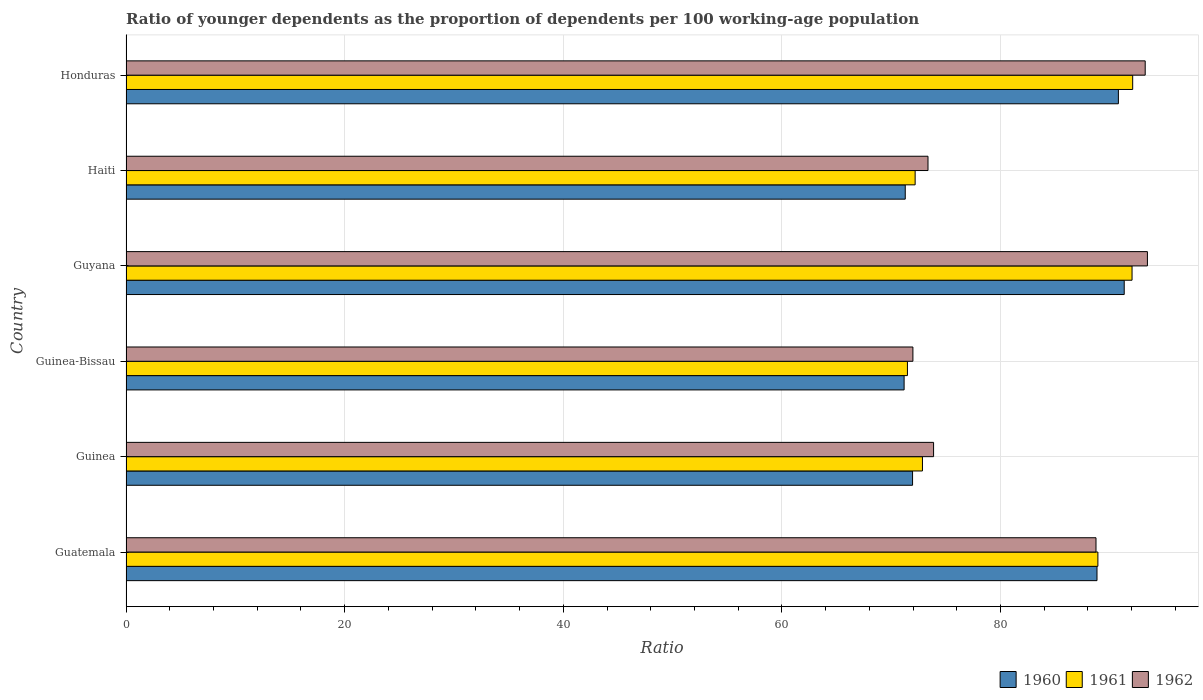Are the number of bars per tick equal to the number of legend labels?
Make the answer very short. Yes. Are the number of bars on each tick of the Y-axis equal?
Your response must be concise. Yes. How many bars are there on the 2nd tick from the top?
Your response must be concise. 3. How many bars are there on the 4th tick from the bottom?
Your answer should be very brief. 3. What is the label of the 5th group of bars from the top?
Ensure brevity in your answer.  Guinea. In how many cases, is the number of bars for a given country not equal to the number of legend labels?
Offer a terse response. 0. What is the age dependency ratio(young) in 1961 in Guyana?
Make the answer very short. 92.03. Across all countries, what is the maximum age dependency ratio(young) in 1961?
Your response must be concise. 92.09. Across all countries, what is the minimum age dependency ratio(young) in 1962?
Ensure brevity in your answer.  71.98. In which country was the age dependency ratio(young) in 1962 maximum?
Ensure brevity in your answer.  Guyana. In which country was the age dependency ratio(young) in 1962 minimum?
Your response must be concise. Guinea-Bissau. What is the total age dependency ratio(young) in 1962 in the graph?
Ensure brevity in your answer.  494.63. What is the difference between the age dependency ratio(young) in 1962 in Guatemala and that in Honduras?
Offer a very short reply. -4.5. What is the difference between the age dependency ratio(young) in 1962 in Guyana and the age dependency ratio(young) in 1960 in Guinea?
Offer a very short reply. 21.49. What is the average age dependency ratio(young) in 1961 per country?
Give a very brief answer. 81.59. What is the difference between the age dependency ratio(young) in 1961 and age dependency ratio(young) in 1960 in Haiti?
Keep it short and to the point. 0.9. What is the ratio of the age dependency ratio(young) in 1960 in Guinea-Bissau to that in Guyana?
Keep it short and to the point. 0.78. Is the age dependency ratio(young) in 1960 in Guatemala less than that in Haiti?
Provide a short and direct response. No. Is the difference between the age dependency ratio(young) in 1961 in Guatemala and Guinea-Bissau greater than the difference between the age dependency ratio(young) in 1960 in Guatemala and Guinea-Bissau?
Ensure brevity in your answer.  No. What is the difference between the highest and the second highest age dependency ratio(young) in 1960?
Your response must be concise. 0.53. What is the difference between the highest and the lowest age dependency ratio(young) in 1962?
Offer a very short reply. 21.45. Is the sum of the age dependency ratio(young) in 1962 in Guatemala and Guinea greater than the maximum age dependency ratio(young) in 1960 across all countries?
Your answer should be very brief. Yes. Are all the bars in the graph horizontal?
Provide a succinct answer. Yes. What is the difference between two consecutive major ticks on the X-axis?
Make the answer very short. 20. Are the values on the major ticks of X-axis written in scientific E-notation?
Your response must be concise. No. Does the graph contain any zero values?
Give a very brief answer. No. Does the graph contain grids?
Your answer should be compact. Yes. Where does the legend appear in the graph?
Your answer should be compact. Bottom right. How many legend labels are there?
Offer a very short reply. 3. How are the legend labels stacked?
Your response must be concise. Horizontal. What is the title of the graph?
Provide a short and direct response. Ratio of younger dependents as the proportion of dependents per 100 working-age population. What is the label or title of the X-axis?
Your response must be concise. Ratio. What is the label or title of the Y-axis?
Give a very brief answer. Country. What is the Ratio of 1960 in Guatemala?
Provide a succinct answer. 88.83. What is the Ratio of 1961 in Guatemala?
Offer a very short reply. 88.91. What is the Ratio of 1962 in Guatemala?
Give a very brief answer. 88.73. What is the Ratio of 1960 in Guinea?
Provide a succinct answer. 71.95. What is the Ratio of 1961 in Guinea?
Keep it short and to the point. 72.86. What is the Ratio in 1962 in Guinea?
Provide a short and direct response. 73.88. What is the Ratio of 1960 in Guinea-Bissau?
Offer a very short reply. 71.18. What is the Ratio of 1961 in Guinea-Bissau?
Your answer should be very brief. 71.48. What is the Ratio of 1962 in Guinea-Bissau?
Ensure brevity in your answer.  71.98. What is the Ratio of 1960 in Guyana?
Your answer should be very brief. 91.31. What is the Ratio of 1961 in Guyana?
Offer a terse response. 92.03. What is the Ratio in 1962 in Guyana?
Your response must be concise. 93.44. What is the Ratio in 1960 in Haiti?
Provide a succinct answer. 71.28. What is the Ratio of 1961 in Haiti?
Provide a succinct answer. 72.19. What is the Ratio in 1962 in Haiti?
Offer a terse response. 73.37. What is the Ratio of 1960 in Honduras?
Provide a short and direct response. 90.78. What is the Ratio in 1961 in Honduras?
Ensure brevity in your answer.  92.09. What is the Ratio in 1962 in Honduras?
Your response must be concise. 93.23. Across all countries, what is the maximum Ratio in 1960?
Give a very brief answer. 91.31. Across all countries, what is the maximum Ratio of 1961?
Provide a short and direct response. 92.09. Across all countries, what is the maximum Ratio in 1962?
Provide a succinct answer. 93.44. Across all countries, what is the minimum Ratio of 1960?
Give a very brief answer. 71.18. Across all countries, what is the minimum Ratio in 1961?
Offer a terse response. 71.48. Across all countries, what is the minimum Ratio in 1962?
Your response must be concise. 71.98. What is the total Ratio of 1960 in the graph?
Your response must be concise. 485.34. What is the total Ratio of 1961 in the graph?
Offer a very short reply. 489.56. What is the total Ratio in 1962 in the graph?
Your answer should be compact. 494.63. What is the difference between the Ratio of 1960 in Guatemala and that in Guinea?
Offer a terse response. 16.87. What is the difference between the Ratio of 1961 in Guatemala and that in Guinea?
Keep it short and to the point. 16.05. What is the difference between the Ratio in 1962 in Guatemala and that in Guinea?
Offer a terse response. 14.86. What is the difference between the Ratio in 1960 in Guatemala and that in Guinea-Bissau?
Your answer should be very brief. 17.65. What is the difference between the Ratio in 1961 in Guatemala and that in Guinea-Bissau?
Your answer should be compact. 17.42. What is the difference between the Ratio in 1962 in Guatemala and that in Guinea-Bissau?
Offer a terse response. 16.75. What is the difference between the Ratio in 1960 in Guatemala and that in Guyana?
Give a very brief answer. -2.49. What is the difference between the Ratio of 1961 in Guatemala and that in Guyana?
Make the answer very short. -3.13. What is the difference between the Ratio of 1962 in Guatemala and that in Guyana?
Your response must be concise. -4.7. What is the difference between the Ratio in 1960 in Guatemala and that in Haiti?
Keep it short and to the point. 17.54. What is the difference between the Ratio in 1961 in Guatemala and that in Haiti?
Your response must be concise. 16.72. What is the difference between the Ratio in 1962 in Guatemala and that in Haiti?
Offer a terse response. 15.37. What is the difference between the Ratio in 1960 in Guatemala and that in Honduras?
Give a very brief answer. -1.96. What is the difference between the Ratio of 1961 in Guatemala and that in Honduras?
Keep it short and to the point. -3.18. What is the difference between the Ratio of 1962 in Guatemala and that in Honduras?
Provide a succinct answer. -4.5. What is the difference between the Ratio of 1960 in Guinea and that in Guinea-Bissau?
Provide a short and direct response. 0.77. What is the difference between the Ratio in 1961 in Guinea and that in Guinea-Bissau?
Provide a short and direct response. 1.37. What is the difference between the Ratio in 1962 in Guinea and that in Guinea-Bissau?
Offer a very short reply. 1.89. What is the difference between the Ratio of 1960 in Guinea and that in Guyana?
Your answer should be compact. -19.36. What is the difference between the Ratio of 1961 in Guinea and that in Guyana?
Offer a very short reply. -19.17. What is the difference between the Ratio of 1962 in Guinea and that in Guyana?
Provide a succinct answer. -19.56. What is the difference between the Ratio of 1960 in Guinea and that in Haiti?
Your answer should be very brief. 0.67. What is the difference between the Ratio of 1961 in Guinea and that in Haiti?
Give a very brief answer. 0.67. What is the difference between the Ratio of 1962 in Guinea and that in Haiti?
Keep it short and to the point. 0.51. What is the difference between the Ratio of 1960 in Guinea and that in Honduras?
Provide a short and direct response. -18.83. What is the difference between the Ratio in 1961 in Guinea and that in Honduras?
Offer a very short reply. -19.23. What is the difference between the Ratio in 1962 in Guinea and that in Honduras?
Make the answer very short. -19.36. What is the difference between the Ratio of 1960 in Guinea-Bissau and that in Guyana?
Your answer should be very brief. -20.14. What is the difference between the Ratio of 1961 in Guinea-Bissau and that in Guyana?
Ensure brevity in your answer.  -20.55. What is the difference between the Ratio in 1962 in Guinea-Bissau and that in Guyana?
Make the answer very short. -21.45. What is the difference between the Ratio in 1960 in Guinea-Bissau and that in Haiti?
Offer a terse response. -0.1. What is the difference between the Ratio of 1961 in Guinea-Bissau and that in Haiti?
Keep it short and to the point. -0.7. What is the difference between the Ratio in 1962 in Guinea-Bissau and that in Haiti?
Offer a terse response. -1.38. What is the difference between the Ratio of 1960 in Guinea-Bissau and that in Honduras?
Make the answer very short. -19.6. What is the difference between the Ratio of 1961 in Guinea-Bissau and that in Honduras?
Your response must be concise. -20.61. What is the difference between the Ratio in 1962 in Guinea-Bissau and that in Honduras?
Keep it short and to the point. -21.25. What is the difference between the Ratio of 1960 in Guyana and that in Haiti?
Your answer should be very brief. 20.03. What is the difference between the Ratio in 1961 in Guyana and that in Haiti?
Offer a terse response. 19.84. What is the difference between the Ratio of 1962 in Guyana and that in Haiti?
Your answer should be very brief. 20.07. What is the difference between the Ratio of 1960 in Guyana and that in Honduras?
Your response must be concise. 0.53. What is the difference between the Ratio of 1961 in Guyana and that in Honduras?
Ensure brevity in your answer.  -0.06. What is the difference between the Ratio of 1962 in Guyana and that in Honduras?
Ensure brevity in your answer.  0.2. What is the difference between the Ratio of 1960 in Haiti and that in Honduras?
Make the answer very short. -19.5. What is the difference between the Ratio of 1961 in Haiti and that in Honduras?
Offer a very short reply. -19.9. What is the difference between the Ratio in 1962 in Haiti and that in Honduras?
Provide a short and direct response. -19.87. What is the difference between the Ratio of 1960 in Guatemala and the Ratio of 1961 in Guinea?
Make the answer very short. 15.97. What is the difference between the Ratio in 1960 in Guatemala and the Ratio in 1962 in Guinea?
Provide a succinct answer. 14.95. What is the difference between the Ratio in 1961 in Guatemala and the Ratio in 1962 in Guinea?
Offer a terse response. 15.03. What is the difference between the Ratio in 1960 in Guatemala and the Ratio in 1961 in Guinea-Bissau?
Offer a very short reply. 17.34. What is the difference between the Ratio in 1960 in Guatemala and the Ratio in 1962 in Guinea-Bissau?
Your answer should be very brief. 16.84. What is the difference between the Ratio of 1961 in Guatemala and the Ratio of 1962 in Guinea-Bissau?
Make the answer very short. 16.92. What is the difference between the Ratio of 1960 in Guatemala and the Ratio of 1961 in Guyana?
Provide a short and direct response. -3.21. What is the difference between the Ratio of 1960 in Guatemala and the Ratio of 1962 in Guyana?
Your answer should be very brief. -4.61. What is the difference between the Ratio in 1961 in Guatemala and the Ratio in 1962 in Guyana?
Offer a terse response. -4.53. What is the difference between the Ratio of 1960 in Guatemala and the Ratio of 1961 in Haiti?
Offer a terse response. 16.64. What is the difference between the Ratio in 1960 in Guatemala and the Ratio in 1962 in Haiti?
Offer a very short reply. 15.46. What is the difference between the Ratio in 1961 in Guatemala and the Ratio in 1962 in Haiti?
Provide a succinct answer. 15.54. What is the difference between the Ratio in 1960 in Guatemala and the Ratio in 1961 in Honduras?
Provide a succinct answer. -3.26. What is the difference between the Ratio of 1960 in Guatemala and the Ratio of 1962 in Honduras?
Your answer should be very brief. -4.41. What is the difference between the Ratio in 1961 in Guatemala and the Ratio in 1962 in Honduras?
Offer a very short reply. -4.33. What is the difference between the Ratio of 1960 in Guinea and the Ratio of 1961 in Guinea-Bissau?
Make the answer very short. 0.47. What is the difference between the Ratio in 1960 in Guinea and the Ratio in 1962 in Guinea-Bissau?
Your response must be concise. -0.03. What is the difference between the Ratio of 1961 in Guinea and the Ratio of 1962 in Guinea-Bissau?
Make the answer very short. 0.87. What is the difference between the Ratio in 1960 in Guinea and the Ratio in 1961 in Guyana?
Provide a short and direct response. -20.08. What is the difference between the Ratio of 1960 in Guinea and the Ratio of 1962 in Guyana?
Make the answer very short. -21.49. What is the difference between the Ratio of 1961 in Guinea and the Ratio of 1962 in Guyana?
Your answer should be very brief. -20.58. What is the difference between the Ratio of 1960 in Guinea and the Ratio of 1961 in Haiti?
Provide a succinct answer. -0.24. What is the difference between the Ratio in 1960 in Guinea and the Ratio in 1962 in Haiti?
Your answer should be very brief. -1.41. What is the difference between the Ratio of 1961 in Guinea and the Ratio of 1962 in Haiti?
Your answer should be very brief. -0.51. What is the difference between the Ratio of 1960 in Guinea and the Ratio of 1961 in Honduras?
Your answer should be very brief. -20.14. What is the difference between the Ratio of 1960 in Guinea and the Ratio of 1962 in Honduras?
Make the answer very short. -21.28. What is the difference between the Ratio of 1961 in Guinea and the Ratio of 1962 in Honduras?
Ensure brevity in your answer.  -20.38. What is the difference between the Ratio in 1960 in Guinea-Bissau and the Ratio in 1961 in Guyana?
Your answer should be compact. -20.85. What is the difference between the Ratio of 1960 in Guinea-Bissau and the Ratio of 1962 in Guyana?
Provide a short and direct response. -22.26. What is the difference between the Ratio in 1961 in Guinea-Bissau and the Ratio in 1962 in Guyana?
Ensure brevity in your answer.  -21.95. What is the difference between the Ratio of 1960 in Guinea-Bissau and the Ratio of 1961 in Haiti?
Offer a terse response. -1.01. What is the difference between the Ratio in 1960 in Guinea-Bissau and the Ratio in 1962 in Haiti?
Keep it short and to the point. -2.19. What is the difference between the Ratio in 1961 in Guinea-Bissau and the Ratio in 1962 in Haiti?
Make the answer very short. -1.88. What is the difference between the Ratio in 1960 in Guinea-Bissau and the Ratio in 1961 in Honduras?
Your response must be concise. -20.91. What is the difference between the Ratio in 1960 in Guinea-Bissau and the Ratio in 1962 in Honduras?
Provide a short and direct response. -22.05. What is the difference between the Ratio of 1961 in Guinea-Bissau and the Ratio of 1962 in Honduras?
Your response must be concise. -21.75. What is the difference between the Ratio of 1960 in Guyana and the Ratio of 1961 in Haiti?
Your answer should be compact. 19.13. What is the difference between the Ratio of 1960 in Guyana and the Ratio of 1962 in Haiti?
Your answer should be compact. 17.95. What is the difference between the Ratio of 1961 in Guyana and the Ratio of 1962 in Haiti?
Ensure brevity in your answer.  18.67. What is the difference between the Ratio in 1960 in Guyana and the Ratio in 1961 in Honduras?
Offer a very short reply. -0.78. What is the difference between the Ratio in 1960 in Guyana and the Ratio in 1962 in Honduras?
Provide a short and direct response. -1.92. What is the difference between the Ratio of 1961 in Guyana and the Ratio of 1962 in Honduras?
Offer a terse response. -1.2. What is the difference between the Ratio in 1960 in Haiti and the Ratio in 1961 in Honduras?
Ensure brevity in your answer.  -20.81. What is the difference between the Ratio in 1960 in Haiti and the Ratio in 1962 in Honduras?
Provide a succinct answer. -21.95. What is the difference between the Ratio of 1961 in Haiti and the Ratio of 1962 in Honduras?
Your response must be concise. -21.05. What is the average Ratio in 1960 per country?
Your response must be concise. 80.89. What is the average Ratio in 1961 per country?
Give a very brief answer. 81.59. What is the average Ratio in 1962 per country?
Offer a very short reply. 82.44. What is the difference between the Ratio in 1960 and Ratio in 1961 in Guatemala?
Your answer should be very brief. -0.08. What is the difference between the Ratio of 1960 and Ratio of 1962 in Guatemala?
Your answer should be compact. 0.09. What is the difference between the Ratio in 1961 and Ratio in 1962 in Guatemala?
Give a very brief answer. 0.17. What is the difference between the Ratio of 1960 and Ratio of 1961 in Guinea?
Your answer should be compact. -0.91. What is the difference between the Ratio in 1960 and Ratio in 1962 in Guinea?
Your response must be concise. -1.92. What is the difference between the Ratio in 1961 and Ratio in 1962 in Guinea?
Your answer should be very brief. -1.02. What is the difference between the Ratio of 1960 and Ratio of 1961 in Guinea-Bissau?
Provide a short and direct response. -0.3. What is the difference between the Ratio in 1960 and Ratio in 1962 in Guinea-Bissau?
Give a very brief answer. -0.8. What is the difference between the Ratio of 1961 and Ratio of 1962 in Guinea-Bissau?
Your answer should be compact. -0.5. What is the difference between the Ratio of 1960 and Ratio of 1961 in Guyana?
Offer a very short reply. -0.72. What is the difference between the Ratio of 1960 and Ratio of 1962 in Guyana?
Your response must be concise. -2.12. What is the difference between the Ratio in 1961 and Ratio in 1962 in Guyana?
Make the answer very short. -1.41. What is the difference between the Ratio in 1960 and Ratio in 1961 in Haiti?
Ensure brevity in your answer.  -0.9. What is the difference between the Ratio of 1960 and Ratio of 1962 in Haiti?
Your answer should be compact. -2.08. What is the difference between the Ratio of 1961 and Ratio of 1962 in Haiti?
Ensure brevity in your answer.  -1.18. What is the difference between the Ratio in 1960 and Ratio in 1961 in Honduras?
Make the answer very short. -1.31. What is the difference between the Ratio in 1960 and Ratio in 1962 in Honduras?
Offer a terse response. -2.45. What is the difference between the Ratio in 1961 and Ratio in 1962 in Honduras?
Keep it short and to the point. -1.14. What is the ratio of the Ratio in 1960 in Guatemala to that in Guinea?
Offer a terse response. 1.23. What is the ratio of the Ratio in 1961 in Guatemala to that in Guinea?
Your answer should be compact. 1.22. What is the ratio of the Ratio in 1962 in Guatemala to that in Guinea?
Make the answer very short. 1.2. What is the ratio of the Ratio of 1960 in Guatemala to that in Guinea-Bissau?
Your answer should be very brief. 1.25. What is the ratio of the Ratio in 1961 in Guatemala to that in Guinea-Bissau?
Your answer should be compact. 1.24. What is the ratio of the Ratio in 1962 in Guatemala to that in Guinea-Bissau?
Your response must be concise. 1.23. What is the ratio of the Ratio of 1960 in Guatemala to that in Guyana?
Ensure brevity in your answer.  0.97. What is the ratio of the Ratio in 1962 in Guatemala to that in Guyana?
Offer a very short reply. 0.95. What is the ratio of the Ratio of 1960 in Guatemala to that in Haiti?
Offer a terse response. 1.25. What is the ratio of the Ratio of 1961 in Guatemala to that in Haiti?
Provide a succinct answer. 1.23. What is the ratio of the Ratio in 1962 in Guatemala to that in Haiti?
Make the answer very short. 1.21. What is the ratio of the Ratio in 1960 in Guatemala to that in Honduras?
Offer a terse response. 0.98. What is the ratio of the Ratio of 1961 in Guatemala to that in Honduras?
Provide a short and direct response. 0.97. What is the ratio of the Ratio of 1962 in Guatemala to that in Honduras?
Offer a terse response. 0.95. What is the ratio of the Ratio of 1960 in Guinea to that in Guinea-Bissau?
Make the answer very short. 1.01. What is the ratio of the Ratio of 1961 in Guinea to that in Guinea-Bissau?
Your answer should be compact. 1.02. What is the ratio of the Ratio of 1962 in Guinea to that in Guinea-Bissau?
Provide a succinct answer. 1.03. What is the ratio of the Ratio of 1960 in Guinea to that in Guyana?
Your response must be concise. 0.79. What is the ratio of the Ratio of 1961 in Guinea to that in Guyana?
Provide a succinct answer. 0.79. What is the ratio of the Ratio of 1962 in Guinea to that in Guyana?
Keep it short and to the point. 0.79. What is the ratio of the Ratio of 1960 in Guinea to that in Haiti?
Keep it short and to the point. 1.01. What is the ratio of the Ratio in 1961 in Guinea to that in Haiti?
Provide a succinct answer. 1.01. What is the ratio of the Ratio in 1960 in Guinea to that in Honduras?
Keep it short and to the point. 0.79. What is the ratio of the Ratio of 1961 in Guinea to that in Honduras?
Your answer should be very brief. 0.79. What is the ratio of the Ratio of 1962 in Guinea to that in Honduras?
Offer a very short reply. 0.79. What is the ratio of the Ratio in 1960 in Guinea-Bissau to that in Guyana?
Provide a short and direct response. 0.78. What is the ratio of the Ratio in 1961 in Guinea-Bissau to that in Guyana?
Your response must be concise. 0.78. What is the ratio of the Ratio in 1962 in Guinea-Bissau to that in Guyana?
Your answer should be compact. 0.77. What is the ratio of the Ratio in 1961 in Guinea-Bissau to that in Haiti?
Keep it short and to the point. 0.99. What is the ratio of the Ratio of 1962 in Guinea-Bissau to that in Haiti?
Provide a short and direct response. 0.98. What is the ratio of the Ratio in 1960 in Guinea-Bissau to that in Honduras?
Your response must be concise. 0.78. What is the ratio of the Ratio of 1961 in Guinea-Bissau to that in Honduras?
Ensure brevity in your answer.  0.78. What is the ratio of the Ratio in 1962 in Guinea-Bissau to that in Honduras?
Give a very brief answer. 0.77. What is the ratio of the Ratio in 1960 in Guyana to that in Haiti?
Your answer should be very brief. 1.28. What is the ratio of the Ratio of 1961 in Guyana to that in Haiti?
Keep it short and to the point. 1.27. What is the ratio of the Ratio in 1962 in Guyana to that in Haiti?
Your response must be concise. 1.27. What is the ratio of the Ratio of 1960 in Guyana to that in Honduras?
Make the answer very short. 1.01. What is the ratio of the Ratio of 1960 in Haiti to that in Honduras?
Your response must be concise. 0.79. What is the ratio of the Ratio in 1961 in Haiti to that in Honduras?
Make the answer very short. 0.78. What is the ratio of the Ratio in 1962 in Haiti to that in Honduras?
Your response must be concise. 0.79. What is the difference between the highest and the second highest Ratio in 1960?
Give a very brief answer. 0.53. What is the difference between the highest and the second highest Ratio of 1961?
Give a very brief answer. 0.06. What is the difference between the highest and the second highest Ratio in 1962?
Your answer should be very brief. 0.2. What is the difference between the highest and the lowest Ratio in 1960?
Your response must be concise. 20.14. What is the difference between the highest and the lowest Ratio of 1961?
Offer a very short reply. 20.61. What is the difference between the highest and the lowest Ratio in 1962?
Keep it short and to the point. 21.45. 